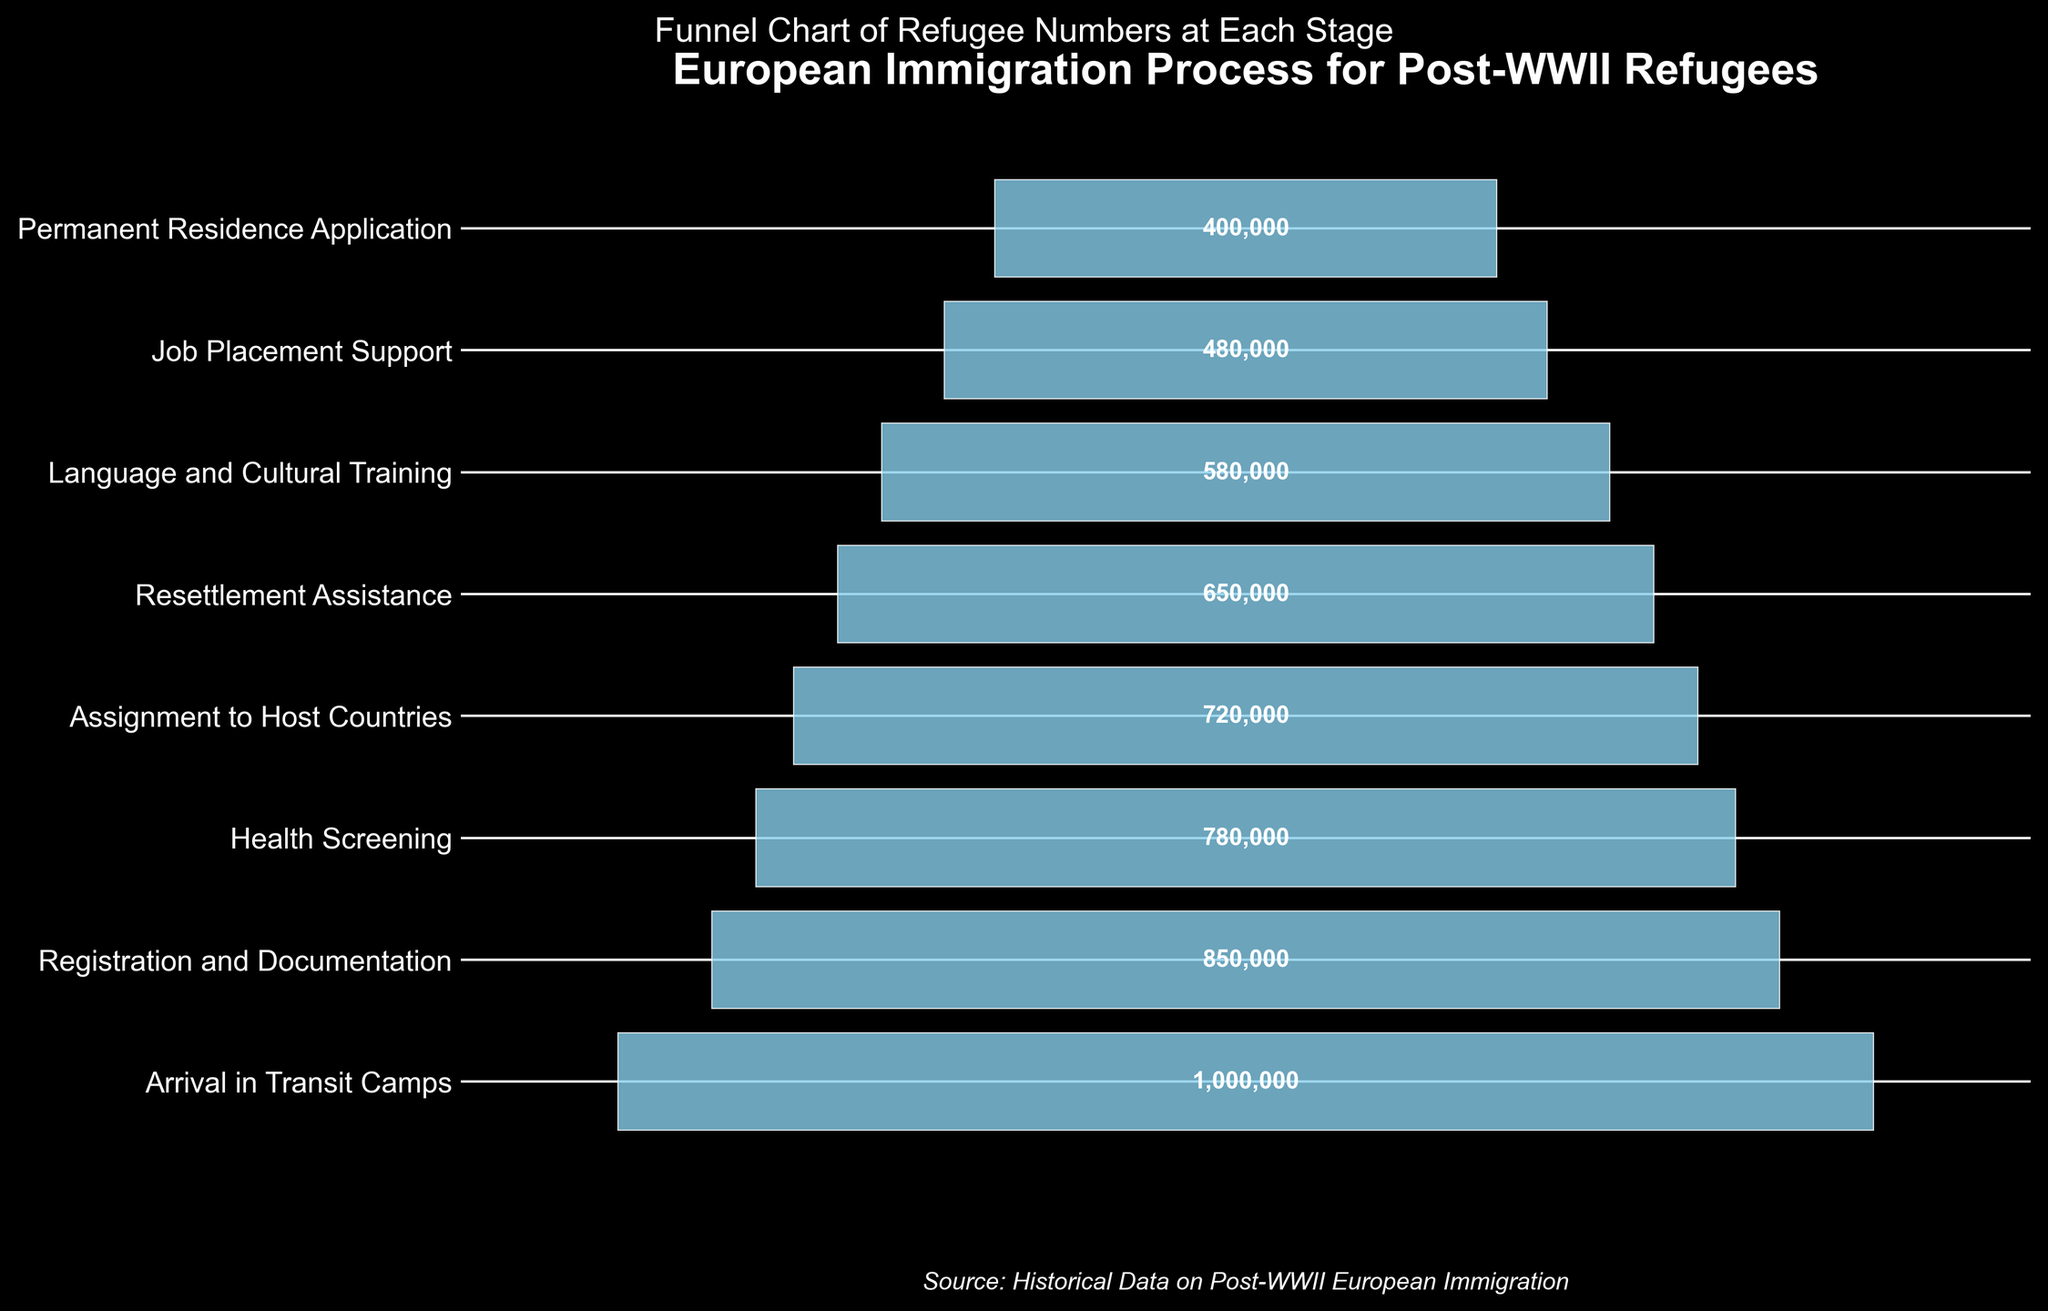What is the title of the funnel chart? The title is displayed at the top of the figure in large, bold text. The title reads "European Immigration Process for Post-WWII Refugees".
Answer: European Immigration Process for Post-WWII Refugees How many main stages are shown in the funnel chart? Each horizontal bar represents a distinct stage and there are 8 horizontal bars shown.
Answer: 8 What stage retains the highest number of refugees? The first stage has the widest bar which represents the highest number of refugees. The label shows this stage is "Arrival in Transit Camps" with 1,000,000 refugees.
Answer: Arrival in Transit Camps How many refugees undergo health screening? The number of refugees at the "Health Screening" stage is written inside the bar, showing 780,000 refugees.
Answer: 780,000 What is the difference in the number of refugees between "Job Placement Support" and "Permanent Residence Application"? Subtract the 400,000 refugees at the "Permanent Residence Application" stage from the 480,000 refugees at the "Job Placement Support" stage. \(480,000 - 400,000 = 80,000\).
Answer: 80,000 What is the average number of refugees across all stages? Calculate the total number of refugees across all stages: \(1,000,000 + 850,000 + 780,000 + 720,000 + 650,000 + 580,000 + 480,000 + 400,000 = 5,460,000\). Divide by the number of stages (8): \(5,460,000 / 8 = 682,500\).
Answer: 682,500 Which stage has the smallest number of refugees? The narrowest bar represents the smallest number of refugees, labeled "Permanent Residence Application" at 400,000.
Answer: Permanent Residence Application What is the cumulative reduction in the number of refugees from "Arrival in Transit Camps" to "Language and Cultural Training"? Subtract the number of refugees at "Language and Cultural Training" from "Arrival in Transit Camps": \(1,000,000 - 580,000 = 420,000\).
Answer: 420,000 How does the number of refugees in "Resettlement Assistance" compare to "Language and Cultural Training"? Subtract the number of refugees in "Language and Cultural Training" from "Resettlement Assistance": \(650,000 - 580,000 = 70,000\). Therefore, "Resettlement Assistance" has 70,000 more refugees.
Answer: 70,000 more refugees in Resettlement Assistance 